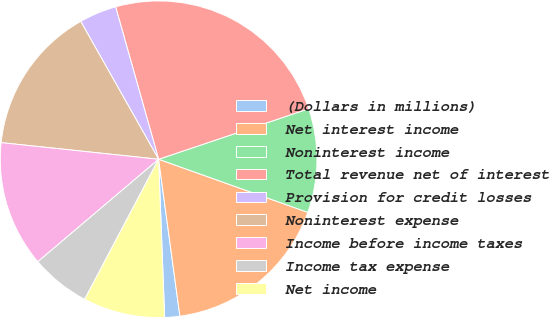Convert chart to OTSL. <chart><loc_0><loc_0><loc_500><loc_500><pie_chart><fcel>(Dollars in millions)<fcel>Net interest income<fcel>Noninterest income<fcel>Total revenue net of interest<fcel>Provision for credit losses<fcel>Noninterest expense<fcel>Income before income taxes<fcel>Income tax expense<fcel>Net income<nl><fcel>1.54%<fcel>17.41%<fcel>10.61%<fcel>24.21%<fcel>3.81%<fcel>15.14%<fcel>12.87%<fcel>6.07%<fcel>8.34%<nl></chart> 